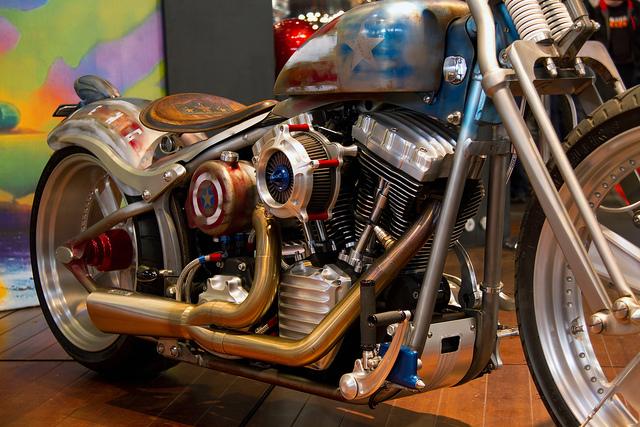How many wheels does this have?
Answer briefly. 2. Would one ride this bike on this surface?
Keep it brief. No. Is this a vintage motorcycle?
Keep it brief. Yes. How many bikes are in the photo?
Give a very brief answer. 1. Where is the motorcycle?
Give a very brief answer. Inside. 